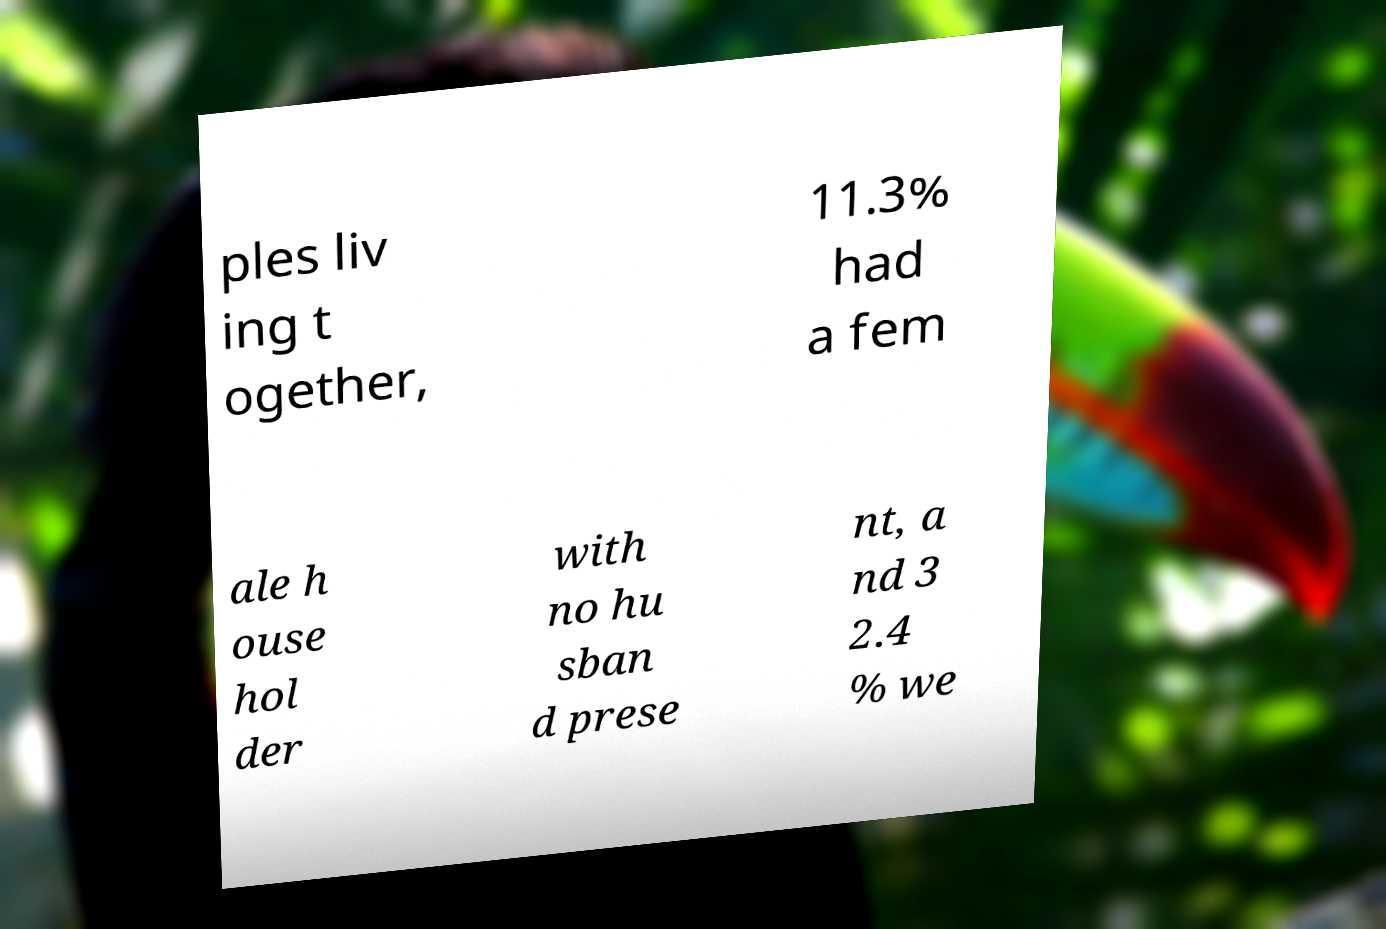Can you accurately transcribe the text from the provided image for me? ples liv ing t ogether, 11.3% had a fem ale h ouse hol der with no hu sban d prese nt, a nd 3 2.4 % we 